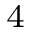<formula> <loc_0><loc_0><loc_500><loc_500>^ { 4 }</formula> 